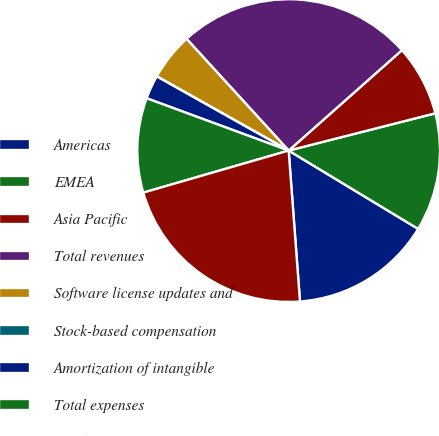Convert chart. <chart><loc_0><loc_0><loc_500><loc_500><pie_chart><fcel>Americas<fcel>EMEA<fcel>Asia Pacific<fcel>Total revenues<fcel>Software license updates and<fcel>Stock-based compensation<fcel>Amortization of intangible<fcel>Total expenses<fcel>Total Margin<nl><fcel>15.15%<fcel>12.62%<fcel>7.58%<fcel>25.24%<fcel>5.06%<fcel>0.01%<fcel>2.53%<fcel>10.1%<fcel>21.71%<nl></chart> 